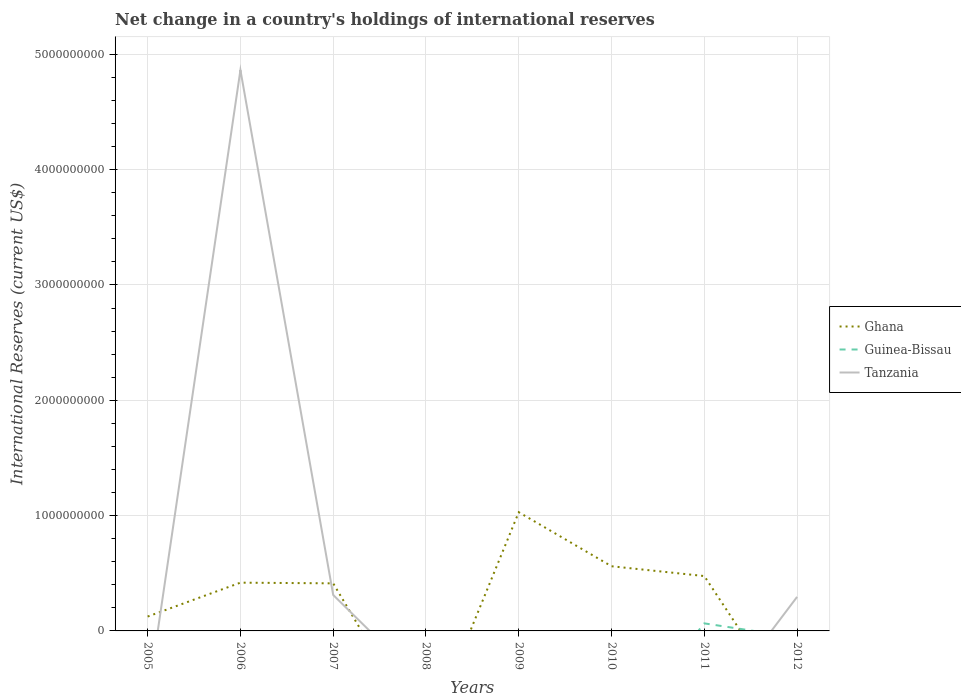How many different coloured lines are there?
Offer a terse response. 3. Does the line corresponding to Tanzania intersect with the line corresponding to Ghana?
Provide a short and direct response. Yes. Across all years, what is the maximum international reserves in Tanzania?
Offer a very short reply. 0. What is the total international reserves in Ghana in the graph?
Your response must be concise. 5.54e+08. What is the difference between the highest and the second highest international reserves in Guinea-Bissau?
Your answer should be compact. 6.54e+07. What is the difference between the highest and the lowest international reserves in Guinea-Bissau?
Keep it short and to the point. 1. Is the international reserves in Tanzania strictly greater than the international reserves in Ghana over the years?
Provide a short and direct response. No. How many years are there in the graph?
Make the answer very short. 8. Does the graph contain any zero values?
Your response must be concise. Yes. Does the graph contain grids?
Give a very brief answer. Yes. Where does the legend appear in the graph?
Provide a short and direct response. Center right. How many legend labels are there?
Your answer should be very brief. 3. What is the title of the graph?
Offer a very short reply. Net change in a country's holdings of international reserves. What is the label or title of the X-axis?
Make the answer very short. Years. What is the label or title of the Y-axis?
Offer a terse response. International Reserves (current US$). What is the International Reserves (current US$) of Ghana in 2005?
Your response must be concise. 1.25e+08. What is the International Reserves (current US$) of Ghana in 2006?
Provide a short and direct response. 4.18e+08. What is the International Reserves (current US$) in Tanzania in 2006?
Keep it short and to the point. 4.86e+09. What is the International Reserves (current US$) in Ghana in 2007?
Make the answer very short. 4.12e+08. What is the International Reserves (current US$) of Guinea-Bissau in 2007?
Your response must be concise. 0. What is the International Reserves (current US$) in Tanzania in 2007?
Your answer should be very brief. 3.12e+08. What is the International Reserves (current US$) of Ghana in 2008?
Provide a short and direct response. 0. What is the International Reserves (current US$) of Ghana in 2009?
Your response must be concise. 1.03e+09. What is the International Reserves (current US$) of Tanzania in 2009?
Your answer should be very brief. 0. What is the International Reserves (current US$) in Ghana in 2010?
Your answer should be very brief. 5.61e+08. What is the International Reserves (current US$) of Guinea-Bissau in 2010?
Offer a very short reply. 0. What is the International Reserves (current US$) in Tanzania in 2010?
Offer a terse response. 0. What is the International Reserves (current US$) of Ghana in 2011?
Provide a short and direct response. 4.76e+08. What is the International Reserves (current US$) in Guinea-Bissau in 2011?
Your answer should be very brief. 6.54e+07. What is the International Reserves (current US$) of Tanzania in 2012?
Offer a terse response. 2.95e+08. Across all years, what is the maximum International Reserves (current US$) of Ghana?
Keep it short and to the point. 1.03e+09. Across all years, what is the maximum International Reserves (current US$) in Guinea-Bissau?
Provide a succinct answer. 6.54e+07. Across all years, what is the maximum International Reserves (current US$) of Tanzania?
Provide a succinct answer. 4.86e+09. Across all years, what is the minimum International Reserves (current US$) in Ghana?
Provide a short and direct response. 0. Across all years, what is the minimum International Reserves (current US$) in Guinea-Bissau?
Give a very brief answer. 0. Across all years, what is the minimum International Reserves (current US$) in Tanzania?
Your response must be concise. 0. What is the total International Reserves (current US$) of Ghana in the graph?
Provide a succinct answer. 3.02e+09. What is the total International Reserves (current US$) of Guinea-Bissau in the graph?
Make the answer very short. 6.54e+07. What is the total International Reserves (current US$) of Tanzania in the graph?
Give a very brief answer. 5.47e+09. What is the difference between the International Reserves (current US$) in Ghana in 2005 and that in 2006?
Ensure brevity in your answer.  -2.94e+08. What is the difference between the International Reserves (current US$) in Ghana in 2005 and that in 2007?
Make the answer very short. -2.88e+08. What is the difference between the International Reserves (current US$) of Ghana in 2005 and that in 2009?
Your response must be concise. -9.05e+08. What is the difference between the International Reserves (current US$) of Ghana in 2005 and that in 2010?
Provide a succinct answer. -4.36e+08. What is the difference between the International Reserves (current US$) in Ghana in 2005 and that in 2011?
Provide a succinct answer. -3.51e+08. What is the difference between the International Reserves (current US$) in Ghana in 2006 and that in 2007?
Make the answer very short. 5.98e+06. What is the difference between the International Reserves (current US$) of Tanzania in 2006 and that in 2007?
Offer a terse response. 4.55e+09. What is the difference between the International Reserves (current US$) of Ghana in 2006 and that in 2009?
Your response must be concise. -6.11e+08. What is the difference between the International Reserves (current US$) in Ghana in 2006 and that in 2010?
Offer a terse response. -1.42e+08. What is the difference between the International Reserves (current US$) in Ghana in 2006 and that in 2011?
Offer a terse response. -5.73e+07. What is the difference between the International Reserves (current US$) of Tanzania in 2006 and that in 2012?
Offer a terse response. 4.57e+09. What is the difference between the International Reserves (current US$) of Ghana in 2007 and that in 2009?
Give a very brief answer. -6.17e+08. What is the difference between the International Reserves (current US$) of Ghana in 2007 and that in 2010?
Your answer should be compact. -1.48e+08. What is the difference between the International Reserves (current US$) in Ghana in 2007 and that in 2011?
Provide a short and direct response. -6.33e+07. What is the difference between the International Reserves (current US$) of Tanzania in 2007 and that in 2012?
Offer a very short reply. 1.65e+07. What is the difference between the International Reserves (current US$) in Ghana in 2009 and that in 2010?
Provide a succinct answer. 4.69e+08. What is the difference between the International Reserves (current US$) of Ghana in 2009 and that in 2011?
Your answer should be very brief. 5.54e+08. What is the difference between the International Reserves (current US$) in Ghana in 2010 and that in 2011?
Your response must be concise. 8.49e+07. What is the difference between the International Reserves (current US$) of Ghana in 2005 and the International Reserves (current US$) of Tanzania in 2006?
Provide a succinct answer. -4.74e+09. What is the difference between the International Reserves (current US$) in Ghana in 2005 and the International Reserves (current US$) in Tanzania in 2007?
Ensure brevity in your answer.  -1.87e+08. What is the difference between the International Reserves (current US$) of Ghana in 2005 and the International Reserves (current US$) of Guinea-Bissau in 2011?
Give a very brief answer. 5.92e+07. What is the difference between the International Reserves (current US$) in Ghana in 2005 and the International Reserves (current US$) in Tanzania in 2012?
Give a very brief answer. -1.70e+08. What is the difference between the International Reserves (current US$) in Ghana in 2006 and the International Reserves (current US$) in Tanzania in 2007?
Offer a terse response. 1.07e+08. What is the difference between the International Reserves (current US$) in Ghana in 2006 and the International Reserves (current US$) in Guinea-Bissau in 2011?
Your response must be concise. 3.53e+08. What is the difference between the International Reserves (current US$) of Ghana in 2006 and the International Reserves (current US$) of Tanzania in 2012?
Your answer should be compact. 1.23e+08. What is the difference between the International Reserves (current US$) of Ghana in 2007 and the International Reserves (current US$) of Guinea-Bissau in 2011?
Give a very brief answer. 3.47e+08. What is the difference between the International Reserves (current US$) in Ghana in 2007 and the International Reserves (current US$) in Tanzania in 2012?
Provide a short and direct response. 1.17e+08. What is the difference between the International Reserves (current US$) in Ghana in 2009 and the International Reserves (current US$) in Guinea-Bissau in 2011?
Make the answer very short. 9.64e+08. What is the difference between the International Reserves (current US$) of Ghana in 2009 and the International Reserves (current US$) of Tanzania in 2012?
Your answer should be very brief. 7.34e+08. What is the difference between the International Reserves (current US$) of Ghana in 2010 and the International Reserves (current US$) of Guinea-Bissau in 2011?
Your response must be concise. 4.95e+08. What is the difference between the International Reserves (current US$) in Ghana in 2010 and the International Reserves (current US$) in Tanzania in 2012?
Give a very brief answer. 2.66e+08. What is the difference between the International Reserves (current US$) of Ghana in 2011 and the International Reserves (current US$) of Tanzania in 2012?
Make the answer very short. 1.81e+08. What is the difference between the International Reserves (current US$) of Guinea-Bissau in 2011 and the International Reserves (current US$) of Tanzania in 2012?
Provide a succinct answer. -2.30e+08. What is the average International Reserves (current US$) of Ghana per year?
Give a very brief answer. 3.78e+08. What is the average International Reserves (current US$) in Guinea-Bissau per year?
Ensure brevity in your answer.  8.18e+06. What is the average International Reserves (current US$) in Tanzania per year?
Your response must be concise. 6.84e+08. In the year 2006, what is the difference between the International Reserves (current US$) in Ghana and International Reserves (current US$) in Tanzania?
Give a very brief answer. -4.44e+09. In the year 2007, what is the difference between the International Reserves (current US$) of Ghana and International Reserves (current US$) of Tanzania?
Your answer should be compact. 1.01e+08. In the year 2011, what is the difference between the International Reserves (current US$) in Ghana and International Reserves (current US$) in Guinea-Bissau?
Provide a short and direct response. 4.10e+08. What is the ratio of the International Reserves (current US$) in Ghana in 2005 to that in 2006?
Your answer should be very brief. 0.3. What is the ratio of the International Reserves (current US$) of Ghana in 2005 to that in 2007?
Provide a short and direct response. 0.3. What is the ratio of the International Reserves (current US$) in Ghana in 2005 to that in 2009?
Provide a succinct answer. 0.12. What is the ratio of the International Reserves (current US$) of Ghana in 2005 to that in 2010?
Offer a very short reply. 0.22. What is the ratio of the International Reserves (current US$) of Ghana in 2005 to that in 2011?
Keep it short and to the point. 0.26. What is the ratio of the International Reserves (current US$) in Ghana in 2006 to that in 2007?
Offer a terse response. 1.01. What is the ratio of the International Reserves (current US$) of Tanzania in 2006 to that in 2007?
Keep it short and to the point. 15.6. What is the ratio of the International Reserves (current US$) of Ghana in 2006 to that in 2009?
Give a very brief answer. 0.41. What is the ratio of the International Reserves (current US$) of Ghana in 2006 to that in 2010?
Provide a short and direct response. 0.75. What is the ratio of the International Reserves (current US$) in Ghana in 2006 to that in 2011?
Ensure brevity in your answer.  0.88. What is the ratio of the International Reserves (current US$) of Tanzania in 2006 to that in 2012?
Your answer should be compact. 16.48. What is the ratio of the International Reserves (current US$) in Ghana in 2007 to that in 2009?
Provide a short and direct response. 0.4. What is the ratio of the International Reserves (current US$) of Ghana in 2007 to that in 2010?
Ensure brevity in your answer.  0.74. What is the ratio of the International Reserves (current US$) in Ghana in 2007 to that in 2011?
Keep it short and to the point. 0.87. What is the ratio of the International Reserves (current US$) in Tanzania in 2007 to that in 2012?
Your response must be concise. 1.06. What is the ratio of the International Reserves (current US$) of Ghana in 2009 to that in 2010?
Give a very brief answer. 1.84. What is the ratio of the International Reserves (current US$) of Ghana in 2009 to that in 2011?
Give a very brief answer. 2.16. What is the ratio of the International Reserves (current US$) in Ghana in 2010 to that in 2011?
Offer a very short reply. 1.18. What is the difference between the highest and the second highest International Reserves (current US$) of Ghana?
Your response must be concise. 4.69e+08. What is the difference between the highest and the second highest International Reserves (current US$) in Tanzania?
Provide a succinct answer. 4.55e+09. What is the difference between the highest and the lowest International Reserves (current US$) in Ghana?
Provide a succinct answer. 1.03e+09. What is the difference between the highest and the lowest International Reserves (current US$) of Guinea-Bissau?
Offer a very short reply. 6.54e+07. What is the difference between the highest and the lowest International Reserves (current US$) in Tanzania?
Provide a short and direct response. 4.86e+09. 